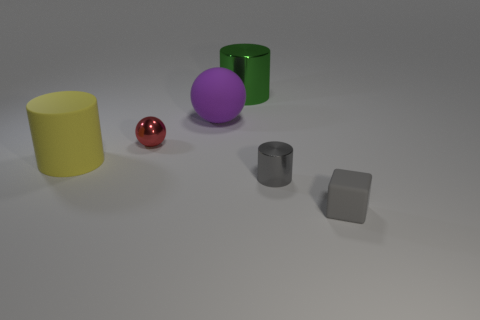Is the small ball the same color as the small cylinder?
Offer a very short reply. No. The yellow matte thing has what size?
Your answer should be compact. Large. There is another thing that is the same shape as the small red shiny object; what size is it?
Ensure brevity in your answer.  Large. How many big spheres are on the right side of the shiny thing that is behind the large purple thing?
Give a very brief answer. 0. Does the small object left of the large shiny object have the same material as the big cylinder behind the yellow matte object?
Offer a very short reply. Yes. What number of other tiny red objects are the same shape as the small rubber object?
Ensure brevity in your answer.  0. How many objects have the same color as the tiny matte block?
Make the answer very short. 1. Does the thing in front of the tiny gray metal cylinder have the same shape as the tiny object that is behind the matte cylinder?
Your answer should be very brief. No. There is a matte object that is in front of the tiny metallic thing on the right side of the large green metallic object; how many matte balls are behind it?
Your answer should be very brief. 1. What is the material of the tiny thing behind the small gray metallic cylinder in front of the metallic cylinder that is behind the tiny red sphere?
Make the answer very short. Metal. 